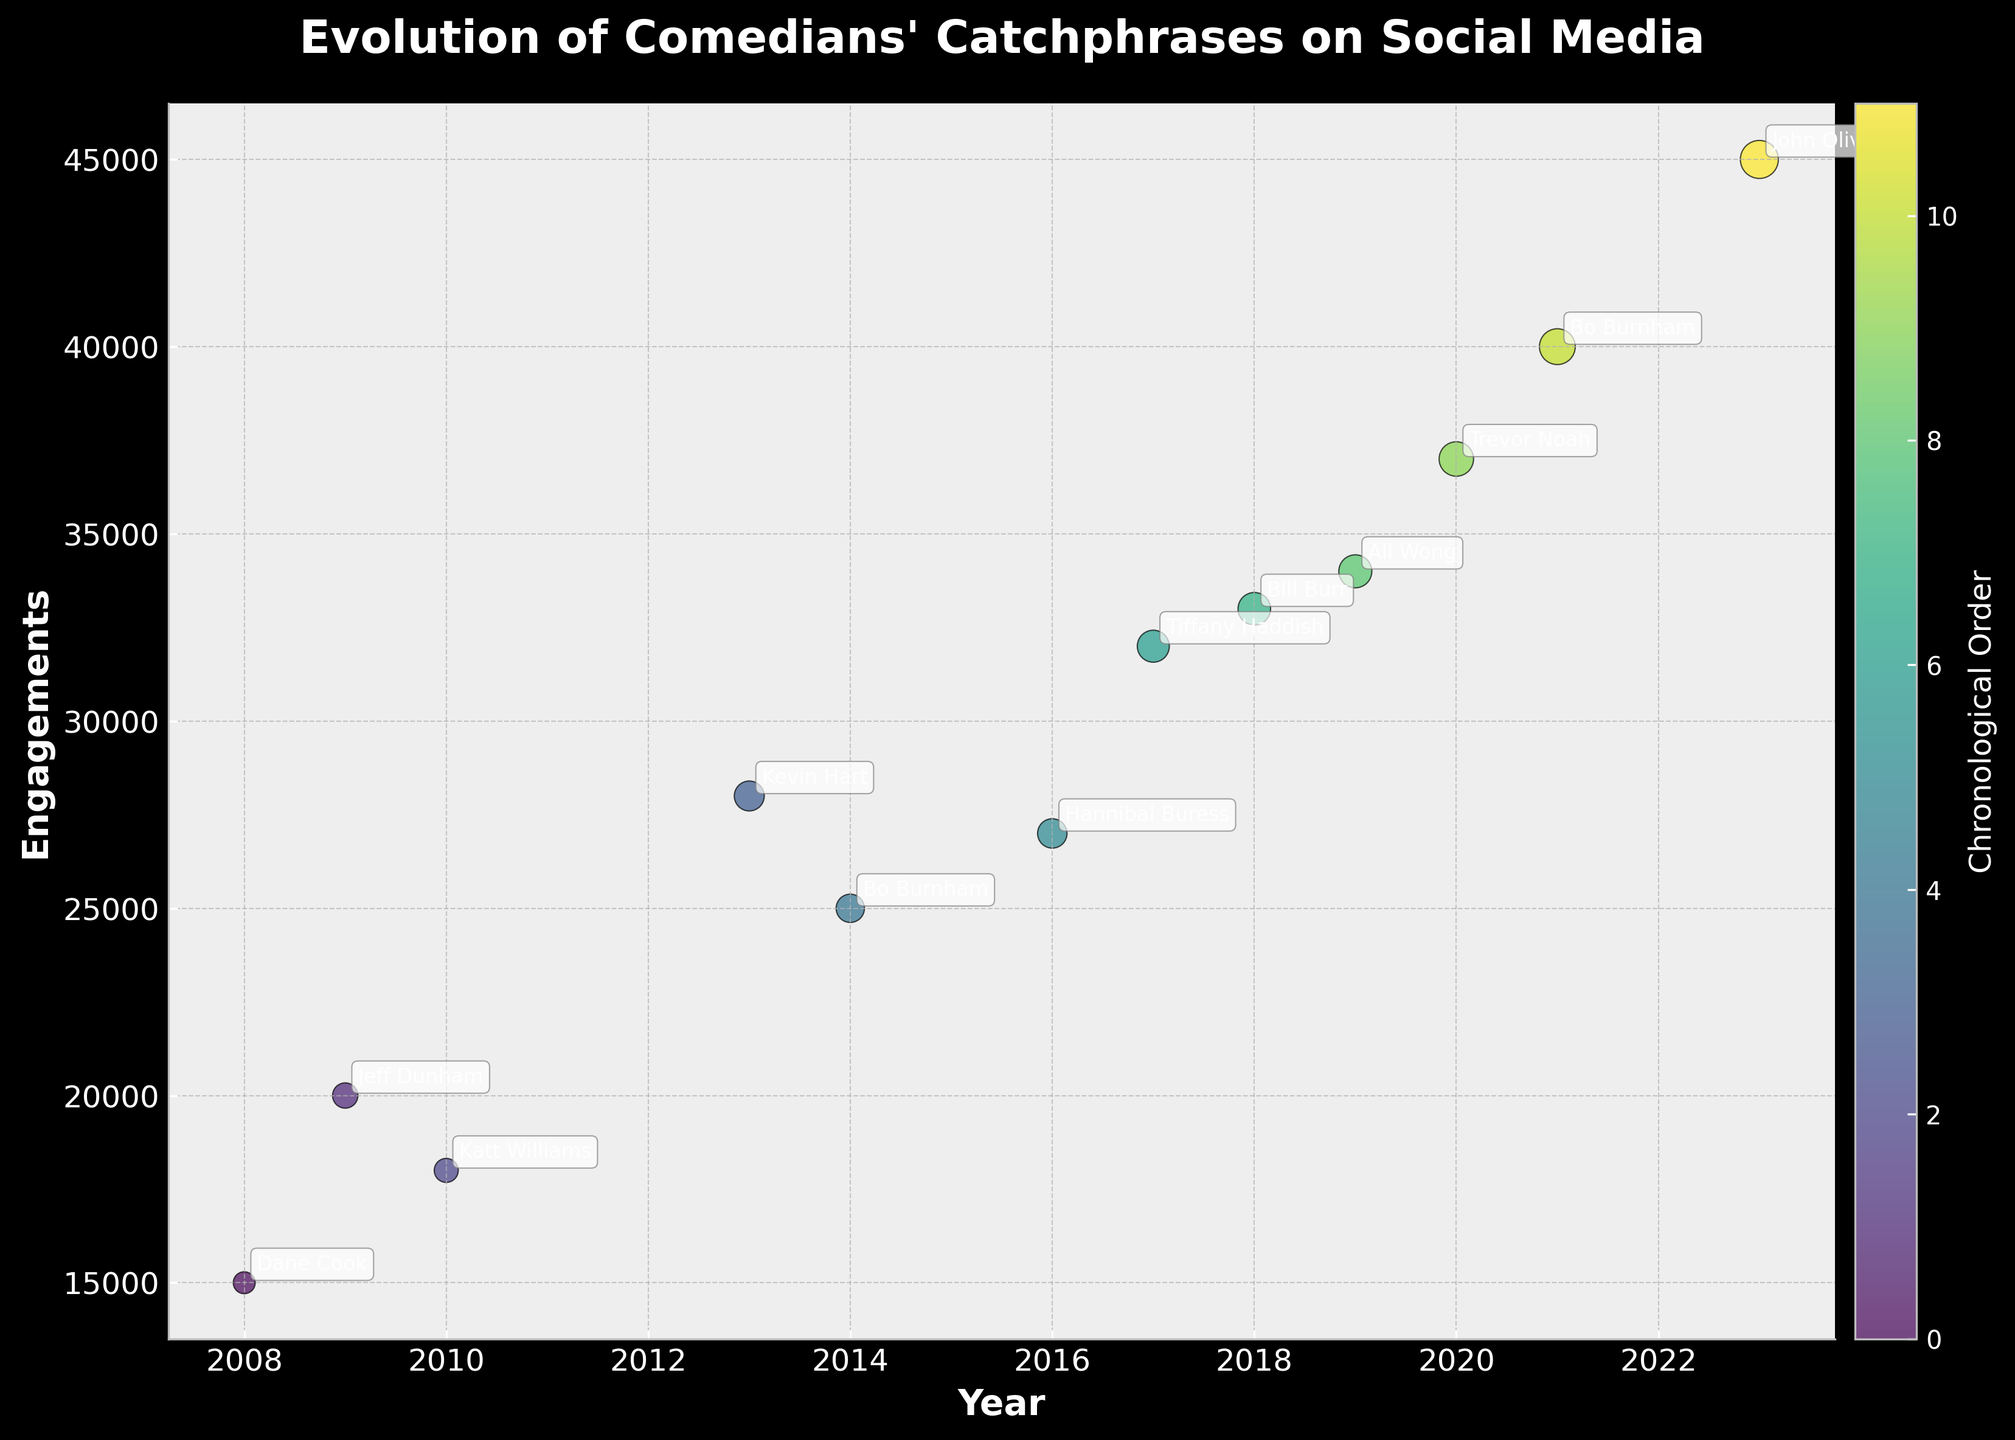Which comedian's catchphrase had the highest engagements in 2023? The year 2023 has the highest engagements, and the comedian mentioned for 2023 is John Oliver.
Answer: John Oliver What is the title of the plot? The title is prominently displayed at the top of the plot and reads "Evolution of Comedians' Catchphrases on Social Media".
Answer: Evolution of Comedians' Catchphrases on Social Media During which year did Kevin Hart's catchphrase have social media mentions? By locating Kevin Hart's annotated name along the x-axis, which represents the years, he appears at the year 2013.
Answer: 2013 How much did social media engagements increase from 2008 to 2023 for catchphrases? The engagements in 2008 were 15000, and in 2023 they were 45000. The increase is calculated as 45000 - 15000.
Answer: 30000 Which year's catchphrase had the least engagement? The smallest data point on the plot or the smallest y-axis value corresponds to the year 2008, with Dane Cook's catchphrase.
Answer: 2008 How many comedians had catchphrases that garnered over 30000 engagements? Engagements exceeding 30000 are achieved by Tiffany Haddish, Bill Burr, Ali Wong, Trevor Noah, Bo Burnham, and John Oliver, summing to 6.
Answer: 6 Who had the second highest social media engagements and what was the catchphrase? By identifying the second highest y-value on the plot, the comedian is Bo Burnham in 2021 with the catchphrase "Inside Again".
Answer: Bo Burnham, Inside Again What is the average social media engagement for the given years? Summing all engagements (15000+20000+18000+28000+25000+27000+32000+33000+34000+37000+40000+45000) = 386000, then dividing by 12 (the number of years).
Answer: 32166.67 Between which consecutive years did engagements see the largest increase? By evaluating the year-on-year difference: Between 2020 (37000) and 2021 (40000) the increase is 3000. In other years, changes are smaller.
Answer: From 2020 to 2021 Which comedian catchphrase in 2019 can be identified from the plot? Looking at the plot's data point for the year 2019, the annotation shows that the comedian is Ali Wong with "I’m Gonna Kick That Little Light-Skinned Bitch’s Ass".
Answer: Ali Wong 